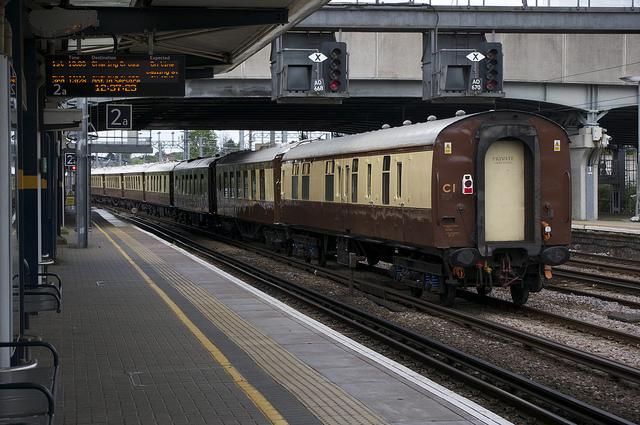What platform is the train at?
Write a very short answer. 2. What color is the train?
Short answer required. Brown. What time does the train arrive?
Quick response, please. 10:00. Is this the rear of the train?
Quick response, please. Yes. What does the sign say?
Answer briefly. 2a. Is this an old train?
Write a very short answer. Yes. What color is the bench?
Give a very brief answer. Black. What is this train's destination?
Quick response, please. City. What colors are the train?
Answer briefly. Brown and tan. What time is it?
Be succinct. Noon. What number is below the light?
Short answer required. 2. Can the train go fast?
Give a very brief answer. Yes. Does every door open on this train?
Answer briefly. Yes. According to the signs, which side is number 2?
Short answer required. Left. 